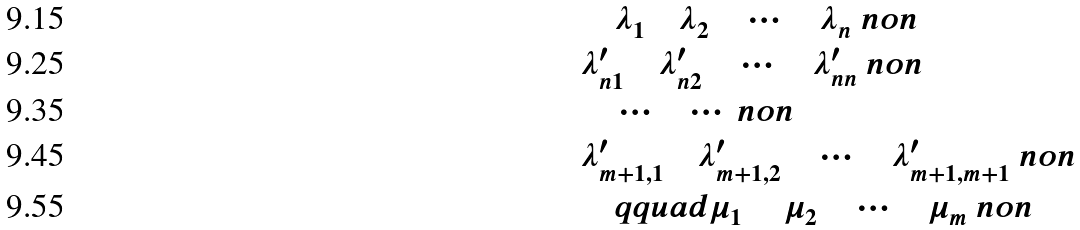<formula> <loc_0><loc_0><loc_500><loc_500>& \quad \lambda _ { 1 } \quad \lambda _ { 2 } \quad \cdots \quad \lambda _ { n } \ n o n \\ & \lambda ^ { \prime } _ { n 1 } \quad \lambda ^ { \prime } _ { n 2 } \quad \cdots \quad \lambda ^ { \prime } _ { n n } \ n o n \\ & \quad \cdots \quad \cdots \ n o n \\ & \lambda ^ { \prime } _ { m + 1 , 1 } \quad \lambda ^ { \prime } _ { m + 1 , 2 } \quad \cdots \quad \lambda ^ { \prime } _ { m + 1 , m + 1 } \ n o n \\ \quad & \quad q q u a d \mu _ { 1 } \quad \ \mu _ { 2 } \quad \cdots \quad \mu _ { m } \ n o n</formula> 